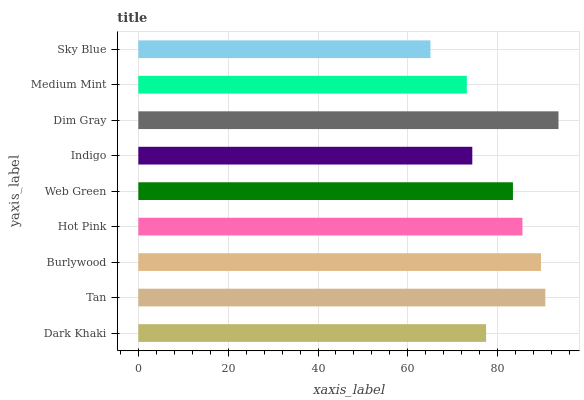Is Sky Blue the minimum?
Answer yes or no. Yes. Is Dim Gray the maximum?
Answer yes or no. Yes. Is Tan the minimum?
Answer yes or no. No. Is Tan the maximum?
Answer yes or no. No. Is Tan greater than Dark Khaki?
Answer yes or no. Yes. Is Dark Khaki less than Tan?
Answer yes or no. Yes. Is Dark Khaki greater than Tan?
Answer yes or no. No. Is Tan less than Dark Khaki?
Answer yes or no. No. Is Web Green the high median?
Answer yes or no. Yes. Is Web Green the low median?
Answer yes or no. Yes. Is Medium Mint the high median?
Answer yes or no. No. Is Burlywood the low median?
Answer yes or no. No. 